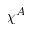Convert formula to latex. <formula><loc_0><loc_0><loc_500><loc_500>\chi ^ { A }</formula> 